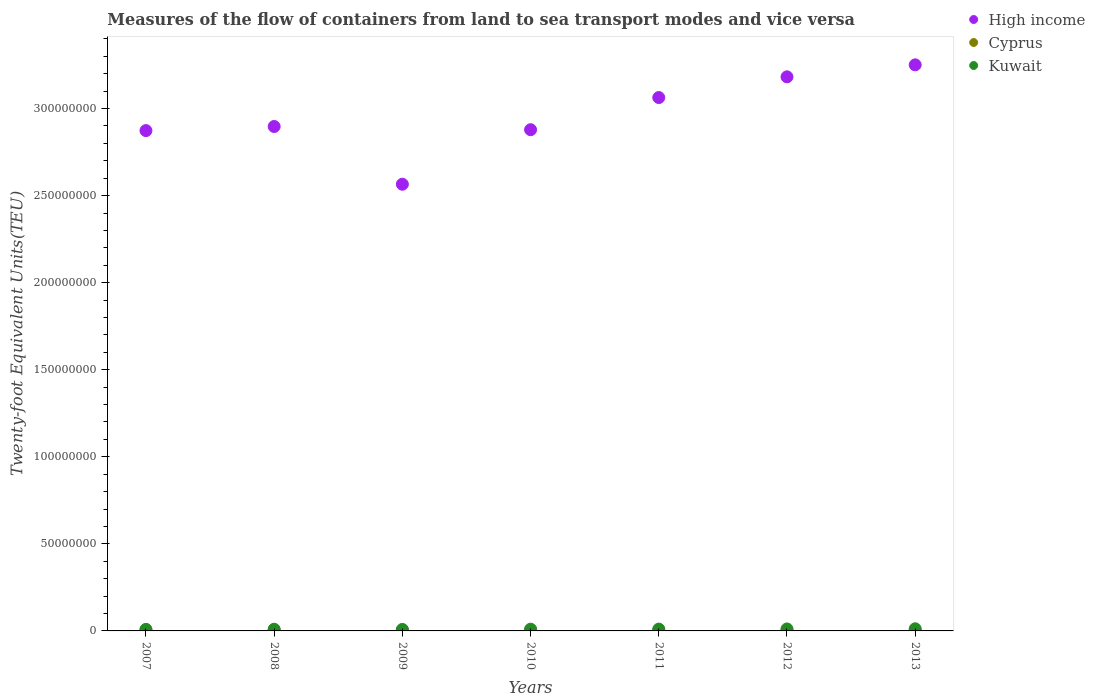Is the number of dotlines equal to the number of legend labels?
Give a very brief answer. Yes. What is the container port traffic in Cyprus in 2013?
Provide a short and direct response. 2.77e+05. Across all years, what is the maximum container port traffic in Cyprus?
Provide a short and direct response. 4.17e+05. Across all years, what is the minimum container port traffic in Cyprus?
Provide a succinct answer. 2.77e+05. What is the total container port traffic in High income in the graph?
Your answer should be compact. 2.07e+09. What is the difference between the container port traffic in Kuwait in 2007 and that in 2013?
Keep it short and to the point. -3.16e+05. What is the difference between the container port traffic in Cyprus in 2008 and the container port traffic in Kuwait in 2012?
Make the answer very short. -7.10e+05. What is the average container port traffic in Cyprus per year?
Keep it short and to the point. 3.49e+05. In the year 2011, what is the difference between the container port traffic in Cyprus and container port traffic in High income?
Provide a short and direct response. -3.06e+08. What is the ratio of the container port traffic in Kuwait in 2007 to that in 2012?
Ensure brevity in your answer.  0.8. Is the difference between the container port traffic in Cyprus in 2008 and 2012 greater than the difference between the container port traffic in High income in 2008 and 2012?
Your answer should be very brief. Yes. What is the difference between the highest and the second highest container port traffic in Cyprus?
Your response must be concise. 3.99e+04. What is the difference between the highest and the lowest container port traffic in High income?
Keep it short and to the point. 6.86e+07. In how many years, is the container port traffic in Kuwait greater than the average container port traffic in Kuwait taken over all years?
Offer a very short reply. 3. Is the sum of the container port traffic in Cyprus in 2007 and 2009 greater than the maximum container port traffic in High income across all years?
Offer a very short reply. No. Does the container port traffic in Kuwait monotonically increase over the years?
Offer a terse response. No. Is the container port traffic in High income strictly greater than the container port traffic in Kuwait over the years?
Provide a short and direct response. Yes. Is the container port traffic in High income strictly less than the container port traffic in Kuwait over the years?
Ensure brevity in your answer.  No. How many years are there in the graph?
Your response must be concise. 7. What is the difference between two consecutive major ticks on the Y-axis?
Provide a short and direct response. 5.00e+07. Does the graph contain any zero values?
Offer a terse response. No. Does the graph contain grids?
Provide a succinct answer. No. How are the legend labels stacked?
Make the answer very short. Vertical. What is the title of the graph?
Offer a terse response. Measures of the flow of containers from land to sea transport modes and vice versa. Does "Rwanda" appear as one of the legend labels in the graph?
Keep it short and to the point. No. What is the label or title of the X-axis?
Your answer should be compact. Years. What is the label or title of the Y-axis?
Ensure brevity in your answer.  Twenty-foot Equivalent Units(TEU). What is the Twenty-foot Equivalent Units(TEU) in High income in 2007?
Offer a very short reply. 2.87e+08. What is the Twenty-foot Equivalent Units(TEU) in Cyprus in 2007?
Offer a terse response. 3.77e+05. What is the Twenty-foot Equivalent Units(TEU) in High income in 2008?
Make the answer very short. 2.90e+08. What is the Twenty-foot Equivalent Units(TEU) of Cyprus in 2008?
Your answer should be very brief. 4.17e+05. What is the Twenty-foot Equivalent Units(TEU) of Kuwait in 2008?
Keep it short and to the point. 9.62e+05. What is the Twenty-foot Equivalent Units(TEU) in High income in 2009?
Offer a very short reply. 2.57e+08. What is the Twenty-foot Equivalent Units(TEU) in Cyprus in 2009?
Ensure brevity in your answer.  3.54e+05. What is the Twenty-foot Equivalent Units(TEU) of Kuwait in 2009?
Keep it short and to the point. 8.54e+05. What is the Twenty-foot Equivalent Units(TEU) in High income in 2010?
Offer a terse response. 2.88e+08. What is the Twenty-foot Equivalent Units(TEU) in Cyprus in 2010?
Give a very brief answer. 3.49e+05. What is the Twenty-foot Equivalent Units(TEU) of Kuwait in 2010?
Provide a succinct answer. 9.92e+05. What is the Twenty-foot Equivalent Units(TEU) in High income in 2011?
Provide a succinct answer. 3.06e+08. What is the Twenty-foot Equivalent Units(TEU) in Cyprus in 2011?
Provide a succinct answer. 3.61e+05. What is the Twenty-foot Equivalent Units(TEU) in Kuwait in 2011?
Keep it short and to the point. 1.05e+06. What is the Twenty-foot Equivalent Units(TEU) of High income in 2012?
Ensure brevity in your answer.  3.18e+08. What is the Twenty-foot Equivalent Units(TEU) in Cyprus in 2012?
Your answer should be very brief. 3.07e+05. What is the Twenty-foot Equivalent Units(TEU) of Kuwait in 2012?
Offer a terse response. 1.13e+06. What is the Twenty-foot Equivalent Units(TEU) of High income in 2013?
Give a very brief answer. 3.25e+08. What is the Twenty-foot Equivalent Units(TEU) of Cyprus in 2013?
Make the answer very short. 2.77e+05. What is the Twenty-foot Equivalent Units(TEU) of Kuwait in 2013?
Ensure brevity in your answer.  1.22e+06. Across all years, what is the maximum Twenty-foot Equivalent Units(TEU) of High income?
Make the answer very short. 3.25e+08. Across all years, what is the maximum Twenty-foot Equivalent Units(TEU) of Cyprus?
Offer a very short reply. 4.17e+05. Across all years, what is the maximum Twenty-foot Equivalent Units(TEU) of Kuwait?
Offer a terse response. 1.22e+06. Across all years, what is the minimum Twenty-foot Equivalent Units(TEU) in High income?
Provide a succinct answer. 2.57e+08. Across all years, what is the minimum Twenty-foot Equivalent Units(TEU) of Cyprus?
Give a very brief answer. 2.77e+05. Across all years, what is the minimum Twenty-foot Equivalent Units(TEU) of Kuwait?
Provide a short and direct response. 8.54e+05. What is the total Twenty-foot Equivalent Units(TEU) of High income in the graph?
Your answer should be very brief. 2.07e+09. What is the total Twenty-foot Equivalent Units(TEU) of Cyprus in the graph?
Your answer should be very brief. 2.44e+06. What is the total Twenty-foot Equivalent Units(TEU) of Kuwait in the graph?
Provide a succinct answer. 7.10e+06. What is the difference between the Twenty-foot Equivalent Units(TEU) of High income in 2007 and that in 2008?
Offer a very short reply. -2.36e+06. What is the difference between the Twenty-foot Equivalent Units(TEU) in Cyprus in 2007 and that in 2008?
Provide a succinct answer. -3.99e+04. What is the difference between the Twenty-foot Equivalent Units(TEU) of Kuwait in 2007 and that in 2008?
Offer a very short reply. -6.17e+04. What is the difference between the Twenty-foot Equivalent Units(TEU) of High income in 2007 and that in 2009?
Provide a short and direct response. 3.08e+07. What is the difference between the Twenty-foot Equivalent Units(TEU) in Cyprus in 2007 and that in 2009?
Make the answer very short. 2.31e+04. What is the difference between the Twenty-foot Equivalent Units(TEU) of Kuwait in 2007 and that in 2009?
Provide a short and direct response. 4.60e+04. What is the difference between the Twenty-foot Equivalent Units(TEU) of High income in 2007 and that in 2010?
Offer a very short reply. -5.10e+05. What is the difference between the Twenty-foot Equivalent Units(TEU) in Cyprus in 2007 and that in 2010?
Make the answer very short. 2.77e+04. What is the difference between the Twenty-foot Equivalent Units(TEU) of Kuwait in 2007 and that in 2010?
Ensure brevity in your answer.  -9.15e+04. What is the difference between the Twenty-foot Equivalent Units(TEU) in High income in 2007 and that in 2011?
Your answer should be compact. -1.90e+07. What is the difference between the Twenty-foot Equivalent Units(TEU) in Cyprus in 2007 and that in 2011?
Give a very brief answer. 1.64e+04. What is the difference between the Twenty-foot Equivalent Units(TEU) in Kuwait in 2007 and that in 2011?
Ensure brevity in your answer.  -1.48e+05. What is the difference between the Twenty-foot Equivalent Units(TEU) of High income in 2007 and that in 2012?
Ensure brevity in your answer.  -3.09e+07. What is the difference between the Twenty-foot Equivalent Units(TEU) of Cyprus in 2007 and that in 2012?
Your response must be concise. 7.00e+04. What is the difference between the Twenty-foot Equivalent Units(TEU) in Kuwait in 2007 and that in 2012?
Provide a succinct answer. -2.27e+05. What is the difference between the Twenty-foot Equivalent Units(TEU) of High income in 2007 and that in 2013?
Provide a succinct answer. -3.78e+07. What is the difference between the Twenty-foot Equivalent Units(TEU) in Cyprus in 2007 and that in 2013?
Make the answer very short. 9.98e+04. What is the difference between the Twenty-foot Equivalent Units(TEU) of Kuwait in 2007 and that in 2013?
Your answer should be very brief. -3.16e+05. What is the difference between the Twenty-foot Equivalent Units(TEU) of High income in 2008 and that in 2009?
Your response must be concise. 3.32e+07. What is the difference between the Twenty-foot Equivalent Units(TEU) of Cyprus in 2008 and that in 2009?
Provide a short and direct response. 6.31e+04. What is the difference between the Twenty-foot Equivalent Units(TEU) of Kuwait in 2008 and that in 2009?
Keep it short and to the point. 1.08e+05. What is the difference between the Twenty-foot Equivalent Units(TEU) in High income in 2008 and that in 2010?
Your answer should be compact. 1.85e+06. What is the difference between the Twenty-foot Equivalent Units(TEU) of Cyprus in 2008 and that in 2010?
Offer a very short reply. 6.76e+04. What is the difference between the Twenty-foot Equivalent Units(TEU) in Kuwait in 2008 and that in 2010?
Offer a terse response. -2.99e+04. What is the difference between the Twenty-foot Equivalent Units(TEU) of High income in 2008 and that in 2011?
Provide a short and direct response. -1.66e+07. What is the difference between the Twenty-foot Equivalent Units(TEU) of Cyprus in 2008 and that in 2011?
Ensure brevity in your answer.  5.63e+04. What is the difference between the Twenty-foot Equivalent Units(TEU) in Kuwait in 2008 and that in 2011?
Your answer should be compact. -8.64e+04. What is the difference between the Twenty-foot Equivalent Units(TEU) of High income in 2008 and that in 2012?
Your answer should be very brief. -2.85e+07. What is the difference between the Twenty-foot Equivalent Units(TEU) in Cyprus in 2008 and that in 2012?
Ensure brevity in your answer.  1.10e+05. What is the difference between the Twenty-foot Equivalent Units(TEU) of Kuwait in 2008 and that in 2012?
Give a very brief answer. -1.65e+05. What is the difference between the Twenty-foot Equivalent Units(TEU) in High income in 2008 and that in 2013?
Make the answer very short. -3.54e+07. What is the difference between the Twenty-foot Equivalent Units(TEU) in Cyprus in 2008 and that in 2013?
Offer a very short reply. 1.40e+05. What is the difference between the Twenty-foot Equivalent Units(TEU) in Kuwait in 2008 and that in 2013?
Offer a very short reply. -2.54e+05. What is the difference between the Twenty-foot Equivalent Units(TEU) of High income in 2009 and that in 2010?
Your response must be concise. -3.13e+07. What is the difference between the Twenty-foot Equivalent Units(TEU) in Cyprus in 2009 and that in 2010?
Provide a short and direct response. 4556. What is the difference between the Twenty-foot Equivalent Units(TEU) of Kuwait in 2009 and that in 2010?
Offer a terse response. -1.38e+05. What is the difference between the Twenty-foot Equivalent Units(TEU) of High income in 2009 and that in 2011?
Your response must be concise. -4.98e+07. What is the difference between the Twenty-foot Equivalent Units(TEU) of Cyprus in 2009 and that in 2011?
Offer a terse response. -6739. What is the difference between the Twenty-foot Equivalent Units(TEU) of Kuwait in 2009 and that in 2011?
Your answer should be compact. -1.94e+05. What is the difference between the Twenty-foot Equivalent Units(TEU) of High income in 2009 and that in 2012?
Ensure brevity in your answer.  -6.17e+07. What is the difference between the Twenty-foot Equivalent Units(TEU) of Cyprus in 2009 and that in 2012?
Give a very brief answer. 4.69e+04. What is the difference between the Twenty-foot Equivalent Units(TEU) in Kuwait in 2009 and that in 2012?
Offer a very short reply. -2.73e+05. What is the difference between the Twenty-foot Equivalent Units(TEU) of High income in 2009 and that in 2013?
Your response must be concise. -6.86e+07. What is the difference between the Twenty-foot Equivalent Units(TEU) in Cyprus in 2009 and that in 2013?
Your response must be concise. 7.66e+04. What is the difference between the Twenty-foot Equivalent Units(TEU) of Kuwait in 2009 and that in 2013?
Your answer should be very brief. -3.62e+05. What is the difference between the Twenty-foot Equivalent Units(TEU) of High income in 2010 and that in 2011?
Give a very brief answer. -1.85e+07. What is the difference between the Twenty-foot Equivalent Units(TEU) in Cyprus in 2010 and that in 2011?
Your answer should be very brief. -1.13e+04. What is the difference between the Twenty-foot Equivalent Units(TEU) in Kuwait in 2010 and that in 2011?
Provide a short and direct response. -5.65e+04. What is the difference between the Twenty-foot Equivalent Units(TEU) of High income in 2010 and that in 2012?
Ensure brevity in your answer.  -3.04e+07. What is the difference between the Twenty-foot Equivalent Units(TEU) of Cyprus in 2010 and that in 2012?
Your response must be concise. 4.23e+04. What is the difference between the Twenty-foot Equivalent Units(TEU) of Kuwait in 2010 and that in 2012?
Make the answer very short. -1.35e+05. What is the difference between the Twenty-foot Equivalent Units(TEU) in High income in 2010 and that in 2013?
Ensure brevity in your answer.  -3.73e+07. What is the difference between the Twenty-foot Equivalent Units(TEU) in Cyprus in 2010 and that in 2013?
Ensure brevity in your answer.  7.21e+04. What is the difference between the Twenty-foot Equivalent Units(TEU) of Kuwait in 2010 and that in 2013?
Offer a very short reply. -2.24e+05. What is the difference between the Twenty-foot Equivalent Units(TEU) of High income in 2011 and that in 2012?
Your response must be concise. -1.19e+07. What is the difference between the Twenty-foot Equivalent Units(TEU) in Cyprus in 2011 and that in 2012?
Make the answer very short. 5.36e+04. What is the difference between the Twenty-foot Equivalent Units(TEU) of Kuwait in 2011 and that in 2012?
Give a very brief answer. -7.86e+04. What is the difference between the Twenty-foot Equivalent Units(TEU) in High income in 2011 and that in 2013?
Offer a terse response. -1.88e+07. What is the difference between the Twenty-foot Equivalent Units(TEU) in Cyprus in 2011 and that in 2013?
Make the answer very short. 8.34e+04. What is the difference between the Twenty-foot Equivalent Units(TEU) of Kuwait in 2011 and that in 2013?
Ensure brevity in your answer.  -1.68e+05. What is the difference between the Twenty-foot Equivalent Units(TEU) of High income in 2012 and that in 2013?
Offer a very short reply. -6.88e+06. What is the difference between the Twenty-foot Equivalent Units(TEU) of Cyprus in 2012 and that in 2013?
Provide a short and direct response. 2.98e+04. What is the difference between the Twenty-foot Equivalent Units(TEU) in Kuwait in 2012 and that in 2013?
Offer a terse response. -8.90e+04. What is the difference between the Twenty-foot Equivalent Units(TEU) in High income in 2007 and the Twenty-foot Equivalent Units(TEU) in Cyprus in 2008?
Your answer should be compact. 2.87e+08. What is the difference between the Twenty-foot Equivalent Units(TEU) of High income in 2007 and the Twenty-foot Equivalent Units(TEU) of Kuwait in 2008?
Offer a very short reply. 2.86e+08. What is the difference between the Twenty-foot Equivalent Units(TEU) in Cyprus in 2007 and the Twenty-foot Equivalent Units(TEU) in Kuwait in 2008?
Make the answer very short. -5.85e+05. What is the difference between the Twenty-foot Equivalent Units(TEU) of High income in 2007 and the Twenty-foot Equivalent Units(TEU) of Cyprus in 2009?
Your answer should be very brief. 2.87e+08. What is the difference between the Twenty-foot Equivalent Units(TEU) of High income in 2007 and the Twenty-foot Equivalent Units(TEU) of Kuwait in 2009?
Offer a very short reply. 2.86e+08. What is the difference between the Twenty-foot Equivalent Units(TEU) in Cyprus in 2007 and the Twenty-foot Equivalent Units(TEU) in Kuwait in 2009?
Keep it short and to the point. -4.77e+05. What is the difference between the Twenty-foot Equivalent Units(TEU) of High income in 2007 and the Twenty-foot Equivalent Units(TEU) of Cyprus in 2010?
Provide a succinct answer. 2.87e+08. What is the difference between the Twenty-foot Equivalent Units(TEU) in High income in 2007 and the Twenty-foot Equivalent Units(TEU) in Kuwait in 2010?
Ensure brevity in your answer.  2.86e+08. What is the difference between the Twenty-foot Equivalent Units(TEU) of Cyprus in 2007 and the Twenty-foot Equivalent Units(TEU) of Kuwait in 2010?
Keep it short and to the point. -6.15e+05. What is the difference between the Twenty-foot Equivalent Units(TEU) in High income in 2007 and the Twenty-foot Equivalent Units(TEU) in Cyprus in 2011?
Your answer should be very brief. 2.87e+08. What is the difference between the Twenty-foot Equivalent Units(TEU) of High income in 2007 and the Twenty-foot Equivalent Units(TEU) of Kuwait in 2011?
Give a very brief answer. 2.86e+08. What is the difference between the Twenty-foot Equivalent Units(TEU) in Cyprus in 2007 and the Twenty-foot Equivalent Units(TEU) in Kuwait in 2011?
Keep it short and to the point. -6.71e+05. What is the difference between the Twenty-foot Equivalent Units(TEU) of High income in 2007 and the Twenty-foot Equivalent Units(TEU) of Cyprus in 2012?
Make the answer very short. 2.87e+08. What is the difference between the Twenty-foot Equivalent Units(TEU) of High income in 2007 and the Twenty-foot Equivalent Units(TEU) of Kuwait in 2012?
Provide a short and direct response. 2.86e+08. What is the difference between the Twenty-foot Equivalent Units(TEU) in Cyprus in 2007 and the Twenty-foot Equivalent Units(TEU) in Kuwait in 2012?
Provide a succinct answer. -7.50e+05. What is the difference between the Twenty-foot Equivalent Units(TEU) of High income in 2007 and the Twenty-foot Equivalent Units(TEU) of Cyprus in 2013?
Your answer should be compact. 2.87e+08. What is the difference between the Twenty-foot Equivalent Units(TEU) in High income in 2007 and the Twenty-foot Equivalent Units(TEU) in Kuwait in 2013?
Provide a succinct answer. 2.86e+08. What is the difference between the Twenty-foot Equivalent Units(TEU) in Cyprus in 2007 and the Twenty-foot Equivalent Units(TEU) in Kuwait in 2013?
Ensure brevity in your answer.  -8.39e+05. What is the difference between the Twenty-foot Equivalent Units(TEU) in High income in 2008 and the Twenty-foot Equivalent Units(TEU) in Cyprus in 2009?
Make the answer very short. 2.89e+08. What is the difference between the Twenty-foot Equivalent Units(TEU) of High income in 2008 and the Twenty-foot Equivalent Units(TEU) of Kuwait in 2009?
Provide a short and direct response. 2.89e+08. What is the difference between the Twenty-foot Equivalent Units(TEU) in Cyprus in 2008 and the Twenty-foot Equivalent Units(TEU) in Kuwait in 2009?
Provide a short and direct response. -4.37e+05. What is the difference between the Twenty-foot Equivalent Units(TEU) of High income in 2008 and the Twenty-foot Equivalent Units(TEU) of Cyprus in 2010?
Your answer should be compact. 2.89e+08. What is the difference between the Twenty-foot Equivalent Units(TEU) in High income in 2008 and the Twenty-foot Equivalent Units(TEU) in Kuwait in 2010?
Give a very brief answer. 2.89e+08. What is the difference between the Twenty-foot Equivalent Units(TEU) in Cyprus in 2008 and the Twenty-foot Equivalent Units(TEU) in Kuwait in 2010?
Ensure brevity in your answer.  -5.75e+05. What is the difference between the Twenty-foot Equivalent Units(TEU) of High income in 2008 and the Twenty-foot Equivalent Units(TEU) of Cyprus in 2011?
Keep it short and to the point. 2.89e+08. What is the difference between the Twenty-foot Equivalent Units(TEU) of High income in 2008 and the Twenty-foot Equivalent Units(TEU) of Kuwait in 2011?
Keep it short and to the point. 2.89e+08. What is the difference between the Twenty-foot Equivalent Units(TEU) of Cyprus in 2008 and the Twenty-foot Equivalent Units(TEU) of Kuwait in 2011?
Keep it short and to the point. -6.31e+05. What is the difference between the Twenty-foot Equivalent Units(TEU) in High income in 2008 and the Twenty-foot Equivalent Units(TEU) in Cyprus in 2012?
Your answer should be compact. 2.89e+08. What is the difference between the Twenty-foot Equivalent Units(TEU) in High income in 2008 and the Twenty-foot Equivalent Units(TEU) in Kuwait in 2012?
Your answer should be very brief. 2.89e+08. What is the difference between the Twenty-foot Equivalent Units(TEU) of Cyprus in 2008 and the Twenty-foot Equivalent Units(TEU) of Kuwait in 2012?
Offer a terse response. -7.10e+05. What is the difference between the Twenty-foot Equivalent Units(TEU) of High income in 2008 and the Twenty-foot Equivalent Units(TEU) of Cyprus in 2013?
Offer a terse response. 2.89e+08. What is the difference between the Twenty-foot Equivalent Units(TEU) of High income in 2008 and the Twenty-foot Equivalent Units(TEU) of Kuwait in 2013?
Make the answer very short. 2.88e+08. What is the difference between the Twenty-foot Equivalent Units(TEU) in Cyprus in 2008 and the Twenty-foot Equivalent Units(TEU) in Kuwait in 2013?
Your answer should be very brief. -7.99e+05. What is the difference between the Twenty-foot Equivalent Units(TEU) in High income in 2009 and the Twenty-foot Equivalent Units(TEU) in Cyprus in 2010?
Offer a terse response. 2.56e+08. What is the difference between the Twenty-foot Equivalent Units(TEU) in High income in 2009 and the Twenty-foot Equivalent Units(TEU) in Kuwait in 2010?
Your answer should be compact. 2.56e+08. What is the difference between the Twenty-foot Equivalent Units(TEU) of Cyprus in 2009 and the Twenty-foot Equivalent Units(TEU) of Kuwait in 2010?
Offer a very short reply. -6.38e+05. What is the difference between the Twenty-foot Equivalent Units(TEU) of High income in 2009 and the Twenty-foot Equivalent Units(TEU) of Cyprus in 2011?
Ensure brevity in your answer.  2.56e+08. What is the difference between the Twenty-foot Equivalent Units(TEU) in High income in 2009 and the Twenty-foot Equivalent Units(TEU) in Kuwait in 2011?
Your answer should be very brief. 2.55e+08. What is the difference between the Twenty-foot Equivalent Units(TEU) of Cyprus in 2009 and the Twenty-foot Equivalent Units(TEU) of Kuwait in 2011?
Provide a short and direct response. -6.94e+05. What is the difference between the Twenty-foot Equivalent Units(TEU) in High income in 2009 and the Twenty-foot Equivalent Units(TEU) in Cyprus in 2012?
Your response must be concise. 2.56e+08. What is the difference between the Twenty-foot Equivalent Units(TEU) of High income in 2009 and the Twenty-foot Equivalent Units(TEU) of Kuwait in 2012?
Make the answer very short. 2.55e+08. What is the difference between the Twenty-foot Equivalent Units(TEU) in Cyprus in 2009 and the Twenty-foot Equivalent Units(TEU) in Kuwait in 2012?
Offer a terse response. -7.73e+05. What is the difference between the Twenty-foot Equivalent Units(TEU) in High income in 2009 and the Twenty-foot Equivalent Units(TEU) in Cyprus in 2013?
Your response must be concise. 2.56e+08. What is the difference between the Twenty-foot Equivalent Units(TEU) of High income in 2009 and the Twenty-foot Equivalent Units(TEU) of Kuwait in 2013?
Your response must be concise. 2.55e+08. What is the difference between the Twenty-foot Equivalent Units(TEU) in Cyprus in 2009 and the Twenty-foot Equivalent Units(TEU) in Kuwait in 2013?
Ensure brevity in your answer.  -8.62e+05. What is the difference between the Twenty-foot Equivalent Units(TEU) in High income in 2010 and the Twenty-foot Equivalent Units(TEU) in Cyprus in 2011?
Provide a short and direct response. 2.87e+08. What is the difference between the Twenty-foot Equivalent Units(TEU) in High income in 2010 and the Twenty-foot Equivalent Units(TEU) in Kuwait in 2011?
Your answer should be very brief. 2.87e+08. What is the difference between the Twenty-foot Equivalent Units(TEU) of Cyprus in 2010 and the Twenty-foot Equivalent Units(TEU) of Kuwait in 2011?
Your answer should be very brief. -6.99e+05. What is the difference between the Twenty-foot Equivalent Units(TEU) in High income in 2010 and the Twenty-foot Equivalent Units(TEU) in Cyprus in 2012?
Keep it short and to the point. 2.88e+08. What is the difference between the Twenty-foot Equivalent Units(TEU) in High income in 2010 and the Twenty-foot Equivalent Units(TEU) in Kuwait in 2012?
Provide a short and direct response. 2.87e+08. What is the difference between the Twenty-foot Equivalent Units(TEU) of Cyprus in 2010 and the Twenty-foot Equivalent Units(TEU) of Kuwait in 2012?
Provide a short and direct response. -7.77e+05. What is the difference between the Twenty-foot Equivalent Units(TEU) of High income in 2010 and the Twenty-foot Equivalent Units(TEU) of Cyprus in 2013?
Offer a very short reply. 2.88e+08. What is the difference between the Twenty-foot Equivalent Units(TEU) of High income in 2010 and the Twenty-foot Equivalent Units(TEU) of Kuwait in 2013?
Ensure brevity in your answer.  2.87e+08. What is the difference between the Twenty-foot Equivalent Units(TEU) of Cyprus in 2010 and the Twenty-foot Equivalent Units(TEU) of Kuwait in 2013?
Your answer should be compact. -8.66e+05. What is the difference between the Twenty-foot Equivalent Units(TEU) in High income in 2011 and the Twenty-foot Equivalent Units(TEU) in Cyprus in 2012?
Make the answer very short. 3.06e+08. What is the difference between the Twenty-foot Equivalent Units(TEU) in High income in 2011 and the Twenty-foot Equivalent Units(TEU) in Kuwait in 2012?
Your response must be concise. 3.05e+08. What is the difference between the Twenty-foot Equivalent Units(TEU) in Cyprus in 2011 and the Twenty-foot Equivalent Units(TEU) in Kuwait in 2012?
Keep it short and to the point. -7.66e+05. What is the difference between the Twenty-foot Equivalent Units(TEU) of High income in 2011 and the Twenty-foot Equivalent Units(TEU) of Cyprus in 2013?
Your response must be concise. 3.06e+08. What is the difference between the Twenty-foot Equivalent Units(TEU) of High income in 2011 and the Twenty-foot Equivalent Units(TEU) of Kuwait in 2013?
Provide a short and direct response. 3.05e+08. What is the difference between the Twenty-foot Equivalent Units(TEU) of Cyprus in 2011 and the Twenty-foot Equivalent Units(TEU) of Kuwait in 2013?
Provide a succinct answer. -8.55e+05. What is the difference between the Twenty-foot Equivalent Units(TEU) in High income in 2012 and the Twenty-foot Equivalent Units(TEU) in Cyprus in 2013?
Offer a terse response. 3.18e+08. What is the difference between the Twenty-foot Equivalent Units(TEU) in High income in 2012 and the Twenty-foot Equivalent Units(TEU) in Kuwait in 2013?
Offer a very short reply. 3.17e+08. What is the difference between the Twenty-foot Equivalent Units(TEU) in Cyprus in 2012 and the Twenty-foot Equivalent Units(TEU) in Kuwait in 2013?
Make the answer very short. -9.09e+05. What is the average Twenty-foot Equivalent Units(TEU) in High income per year?
Offer a terse response. 2.96e+08. What is the average Twenty-foot Equivalent Units(TEU) in Cyprus per year?
Provide a succinct answer. 3.49e+05. What is the average Twenty-foot Equivalent Units(TEU) in Kuwait per year?
Offer a very short reply. 1.01e+06. In the year 2007, what is the difference between the Twenty-foot Equivalent Units(TEU) in High income and Twenty-foot Equivalent Units(TEU) in Cyprus?
Offer a very short reply. 2.87e+08. In the year 2007, what is the difference between the Twenty-foot Equivalent Units(TEU) of High income and Twenty-foot Equivalent Units(TEU) of Kuwait?
Your response must be concise. 2.86e+08. In the year 2007, what is the difference between the Twenty-foot Equivalent Units(TEU) in Cyprus and Twenty-foot Equivalent Units(TEU) in Kuwait?
Offer a terse response. -5.23e+05. In the year 2008, what is the difference between the Twenty-foot Equivalent Units(TEU) of High income and Twenty-foot Equivalent Units(TEU) of Cyprus?
Your answer should be compact. 2.89e+08. In the year 2008, what is the difference between the Twenty-foot Equivalent Units(TEU) of High income and Twenty-foot Equivalent Units(TEU) of Kuwait?
Your response must be concise. 2.89e+08. In the year 2008, what is the difference between the Twenty-foot Equivalent Units(TEU) in Cyprus and Twenty-foot Equivalent Units(TEU) in Kuwait?
Keep it short and to the point. -5.45e+05. In the year 2009, what is the difference between the Twenty-foot Equivalent Units(TEU) in High income and Twenty-foot Equivalent Units(TEU) in Cyprus?
Make the answer very short. 2.56e+08. In the year 2009, what is the difference between the Twenty-foot Equivalent Units(TEU) of High income and Twenty-foot Equivalent Units(TEU) of Kuwait?
Your answer should be compact. 2.56e+08. In the year 2009, what is the difference between the Twenty-foot Equivalent Units(TEU) in Cyprus and Twenty-foot Equivalent Units(TEU) in Kuwait?
Your response must be concise. -5.00e+05. In the year 2010, what is the difference between the Twenty-foot Equivalent Units(TEU) in High income and Twenty-foot Equivalent Units(TEU) in Cyprus?
Keep it short and to the point. 2.87e+08. In the year 2010, what is the difference between the Twenty-foot Equivalent Units(TEU) of High income and Twenty-foot Equivalent Units(TEU) of Kuwait?
Your response must be concise. 2.87e+08. In the year 2010, what is the difference between the Twenty-foot Equivalent Units(TEU) in Cyprus and Twenty-foot Equivalent Units(TEU) in Kuwait?
Your answer should be very brief. -6.42e+05. In the year 2011, what is the difference between the Twenty-foot Equivalent Units(TEU) of High income and Twenty-foot Equivalent Units(TEU) of Cyprus?
Ensure brevity in your answer.  3.06e+08. In the year 2011, what is the difference between the Twenty-foot Equivalent Units(TEU) in High income and Twenty-foot Equivalent Units(TEU) in Kuwait?
Offer a terse response. 3.05e+08. In the year 2011, what is the difference between the Twenty-foot Equivalent Units(TEU) in Cyprus and Twenty-foot Equivalent Units(TEU) in Kuwait?
Provide a succinct answer. -6.87e+05. In the year 2012, what is the difference between the Twenty-foot Equivalent Units(TEU) of High income and Twenty-foot Equivalent Units(TEU) of Cyprus?
Your answer should be very brief. 3.18e+08. In the year 2012, what is the difference between the Twenty-foot Equivalent Units(TEU) in High income and Twenty-foot Equivalent Units(TEU) in Kuwait?
Your answer should be compact. 3.17e+08. In the year 2012, what is the difference between the Twenty-foot Equivalent Units(TEU) of Cyprus and Twenty-foot Equivalent Units(TEU) of Kuwait?
Give a very brief answer. -8.20e+05. In the year 2013, what is the difference between the Twenty-foot Equivalent Units(TEU) of High income and Twenty-foot Equivalent Units(TEU) of Cyprus?
Offer a very short reply. 3.25e+08. In the year 2013, what is the difference between the Twenty-foot Equivalent Units(TEU) in High income and Twenty-foot Equivalent Units(TEU) in Kuwait?
Make the answer very short. 3.24e+08. In the year 2013, what is the difference between the Twenty-foot Equivalent Units(TEU) in Cyprus and Twenty-foot Equivalent Units(TEU) in Kuwait?
Your answer should be very brief. -9.38e+05. What is the ratio of the Twenty-foot Equivalent Units(TEU) of High income in 2007 to that in 2008?
Offer a terse response. 0.99. What is the ratio of the Twenty-foot Equivalent Units(TEU) in Cyprus in 2007 to that in 2008?
Your answer should be compact. 0.9. What is the ratio of the Twenty-foot Equivalent Units(TEU) in Kuwait in 2007 to that in 2008?
Give a very brief answer. 0.94. What is the ratio of the Twenty-foot Equivalent Units(TEU) of High income in 2007 to that in 2009?
Keep it short and to the point. 1.12. What is the ratio of the Twenty-foot Equivalent Units(TEU) of Cyprus in 2007 to that in 2009?
Give a very brief answer. 1.07. What is the ratio of the Twenty-foot Equivalent Units(TEU) in Kuwait in 2007 to that in 2009?
Your answer should be very brief. 1.05. What is the ratio of the Twenty-foot Equivalent Units(TEU) of Cyprus in 2007 to that in 2010?
Offer a terse response. 1.08. What is the ratio of the Twenty-foot Equivalent Units(TEU) of Kuwait in 2007 to that in 2010?
Ensure brevity in your answer.  0.91. What is the ratio of the Twenty-foot Equivalent Units(TEU) in High income in 2007 to that in 2011?
Keep it short and to the point. 0.94. What is the ratio of the Twenty-foot Equivalent Units(TEU) of Cyprus in 2007 to that in 2011?
Give a very brief answer. 1.05. What is the ratio of the Twenty-foot Equivalent Units(TEU) of Kuwait in 2007 to that in 2011?
Provide a short and direct response. 0.86. What is the ratio of the Twenty-foot Equivalent Units(TEU) in High income in 2007 to that in 2012?
Make the answer very short. 0.9. What is the ratio of the Twenty-foot Equivalent Units(TEU) in Cyprus in 2007 to that in 2012?
Provide a succinct answer. 1.23. What is the ratio of the Twenty-foot Equivalent Units(TEU) of Kuwait in 2007 to that in 2012?
Provide a succinct answer. 0.8. What is the ratio of the Twenty-foot Equivalent Units(TEU) in High income in 2007 to that in 2013?
Ensure brevity in your answer.  0.88. What is the ratio of the Twenty-foot Equivalent Units(TEU) of Cyprus in 2007 to that in 2013?
Your answer should be very brief. 1.36. What is the ratio of the Twenty-foot Equivalent Units(TEU) in Kuwait in 2007 to that in 2013?
Give a very brief answer. 0.74. What is the ratio of the Twenty-foot Equivalent Units(TEU) in High income in 2008 to that in 2009?
Your answer should be compact. 1.13. What is the ratio of the Twenty-foot Equivalent Units(TEU) in Cyprus in 2008 to that in 2009?
Keep it short and to the point. 1.18. What is the ratio of the Twenty-foot Equivalent Units(TEU) in Kuwait in 2008 to that in 2009?
Your answer should be very brief. 1.13. What is the ratio of the Twenty-foot Equivalent Units(TEU) of High income in 2008 to that in 2010?
Your response must be concise. 1.01. What is the ratio of the Twenty-foot Equivalent Units(TEU) in Cyprus in 2008 to that in 2010?
Ensure brevity in your answer.  1.19. What is the ratio of the Twenty-foot Equivalent Units(TEU) of Kuwait in 2008 to that in 2010?
Offer a terse response. 0.97. What is the ratio of the Twenty-foot Equivalent Units(TEU) in High income in 2008 to that in 2011?
Ensure brevity in your answer.  0.95. What is the ratio of the Twenty-foot Equivalent Units(TEU) of Cyprus in 2008 to that in 2011?
Your answer should be compact. 1.16. What is the ratio of the Twenty-foot Equivalent Units(TEU) of Kuwait in 2008 to that in 2011?
Make the answer very short. 0.92. What is the ratio of the Twenty-foot Equivalent Units(TEU) in High income in 2008 to that in 2012?
Your answer should be compact. 0.91. What is the ratio of the Twenty-foot Equivalent Units(TEU) in Cyprus in 2008 to that in 2012?
Your answer should be very brief. 1.36. What is the ratio of the Twenty-foot Equivalent Units(TEU) of Kuwait in 2008 to that in 2012?
Your response must be concise. 0.85. What is the ratio of the Twenty-foot Equivalent Units(TEU) of High income in 2008 to that in 2013?
Your answer should be very brief. 0.89. What is the ratio of the Twenty-foot Equivalent Units(TEU) in Cyprus in 2008 to that in 2013?
Provide a succinct answer. 1.5. What is the ratio of the Twenty-foot Equivalent Units(TEU) of Kuwait in 2008 to that in 2013?
Provide a succinct answer. 0.79. What is the ratio of the Twenty-foot Equivalent Units(TEU) in High income in 2009 to that in 2010?
Your answer should be very brief. 0.89. What is the ratio of the Twenty-foot Equivalent Units(TEU) of Cyprus in 2009 to that in 2010?
Ensure brevity in your answer.  1.01. What is the ratio of the Twenty-foot Equivalent Units(TEU) in Kuwait in 2009 to that in 2010?
Give a very brief answer. 0.86. What is the ratio of the Twenty-foot Equivalent Units(TEU) in High income in 2009 to that in 2011?
Offer a very short reply. 0.84. What is the ratio of the Twenty-foot Equivalent Units(TEU) of Cyprus in 2009 to that in 2011?
Ensure brevity in your answer.  0.98. What is the ratio of the Twenty-foot Equivalent Units(TEU) of Kuwait in 2009 to that in 2011?
Keep it short and to the point. 0.81. What is the ratio of the Twenty-foot Equivalent Units(TEU) of High income in 2009 to that in 2012?
Your response must be concise. 0.81. What is the ratio of the Twenty-foot Equivalent Units(TEU) of Cyprus in 2009 to that in 2012?
Your answer should be very brief. 1.15. What is the ratio of the Twenty-foot Equivalent Units(TEU) in Kuwait in 2009 to that in 2012?
Offer a terse response. 0.76. What is the ratio of the Twenty-foot Equivalent Units(TEU) of High income in 2009 to that in 2013?
Your response must be concise. 0.79. What is the ratio of the Twenty-foot Equivalent Units(TEU) of Cyprus in 2009 to that in 2013?
Offer a terse response. 1.28. What is the ratio of the Twenty-foot Equivalent Units(TEU) of Kuwait in 2009 to that in 2013?
Keep it short and to the point. 0.7. What is the ratio of the Twenty-foot Equivalent Units(TEU) of High income in 2010 to that in 2011?
Offer a terse response. 0.94. What is the ratio of the Twenty-foot Equivalent Units(TEU) in Cyprus in 2010 to that in 2011?
Offer a very short reply. 0.97. What is the ratio of the Twenty-foot Equivalent Units(TEU) of Kuwait in 2010 to that in 2011?
Your response must be concise. 0.95. What is the ratio of the Twenty-foot Equivalent Units(TEU) in High income in 2010 to that in 2012?
Your answer should be very brief. 0.9. What is the ratio of the Twenty-foot Equivalent Units(TEU) in Cyprus in 2010 to that in 2012?
Keep it short and to the point. 1.14. What is the ratio of the Twenty-foot Equivalent Units(TEU) in Kuwait in 2010 to that in 2012?
Provide a succinct answer. 0.88. What is the ratio of the Twenty-foot Equivalent Units(TEU) of High income in 2010 to that in 2013?
Keep it short and to the point. 0.89. What is the ratio of the Twenty-foot Equivalent Units(TEU) of Cyprus in 2010 to that in 2013?
Make the answer very short. 1.26. What is the ratio of the Twenty-foot Equivalent Units(TEU) in Kuwait in 2010 to that in 2013?
Provide a short and direct response. 0.82. What is the ratio of the Twenty-foot Equivalent Units(TEU) in High income in 2011 to that in 2012?
Provide a short and direct response. 0.96. What is the ratio of the Twenty-foot Equivalent Units(TEU) in Cyprus in 2011 to that in 2012?
Make the answer very short. 1.17. What is the ratio of the Twenty-foot Equivalent Units(TEU) of Kuwait in 2011 to that in 2012?
Keep it short and to the point. 0.93. What is the ratio of the Twenty-foot Equivalent Units(TEU) in High income in 2011 to that in 2013?
Keep it short and to the point. 0.94. What is the ratio of the Twenty-foot Equivalent Units(TEU) in Cyprus in 2011 to that in 2013?
Keep it short and to the point. 1.3. What is the ratio of the Twenty-foot Equivalent Units(TEU) in Kuwait in 2011 to that in 2013?
Give a very brief answer. 0.86. What is the ratio of the Twenty-foot Equivalent Units(TEU) in High income in 2012 to that in 2013?
Your response must be concise. 0.98. What is the ratio of the Twenty-foot Equivalent Units(TEU) of Cyprus in 2012 to that in 2013?
Offer a very short reply. 1.11. What is the ratio of the Twenty-foot Equivalent Units(TEU) of Kuwait in 2012 to that in 2013?
Ensure brevity in your answer.  0.93. What is the difference between the highest and the second highest Twenty-foot Equivalent Units(TEU) in High income?
Provide a succinct answer. 6.88e+06. What is the difference between the highest and the second highest Twenty-foot Equivalent Units(TEU) in Cyprus?
Your response must be concise. 3.99e+04. What is the difference between the highest and the second highest Twenty-foot Equivalent Units(TEU) in Kuwait?
Your answer should be compact. 8.90e+04. What is the difference between the highest and the lowest Twenty-foot Equivalent Units(TEU) in High income?
Your answer should be compact. 6.86e+07. What is the difference between the highest and the lowest Twenty-foot Equivalent Units(TEU) in Cyprus?
Ensure brevity in your answer.  1.40e+05. What is the difference between the highest and the lowest Twenty-foot Equivalent Units(TEU) in Kuwait?
Your response must be concise. 3.62e+05. 